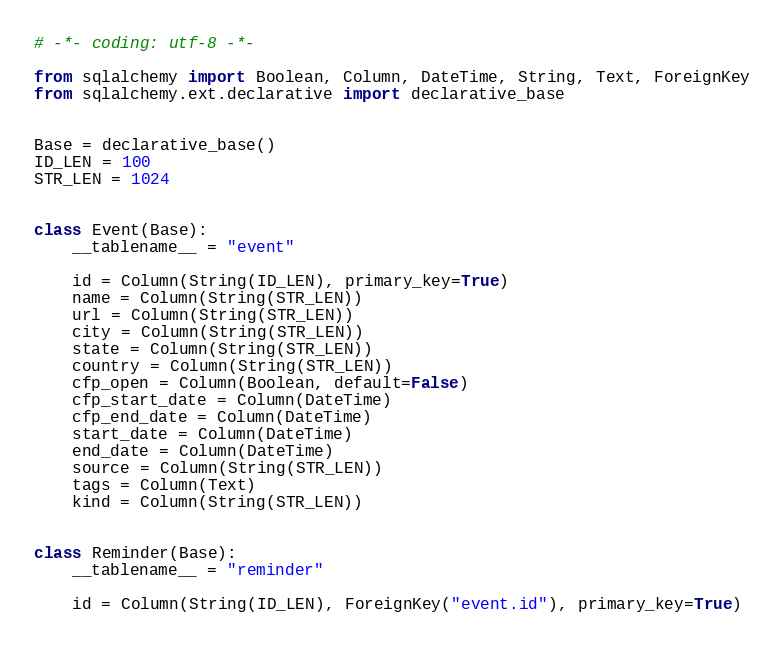Convert code to text. <code><loc_0><loc_0><loc_500><loc_500><_Python_># -*- coding: utf-8 -*-

from sqlalchemy import Boolean, Column, DateTime, String, Text, ForeignKey
from sqlalchemy.ext.declarative import declarative_base


Base = declarative_base()
ID_LEN = 100
STR_LEN = 1024


class Event(Base):
    __tablename__ = "event"

    id = Column(String(ID_LEN), primary_key=True)
    name = Column(String(STR_LEN))
    url = Column(String(STR_LEN))
    city = Column(String(STR_LEN))
    state = Column(String(STR_LEN))
    country = Column(String(STR_LEN))
    cfp_open = Column(Boolean, default=False)
    cfp_start_date = Column(DateTime)
    cfp_end_date = Column(DateTime)
    start_date = Column(DateTime)
    end_date = Column(DateTime)
    source = Column(String(STR_LEN))
    tags = Column(Text)
    kind = Column(String(STR_LEN))


class Reminder(Base):
    __tablename__ = "reminder"

    id = Column(String(ID_LEN), ForeignKey("event.id"), primary_key=True)
</code> 